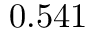<formula> <loc_0><loc_0><loc_500><loc_500>0 . 5 4 1</formula> 